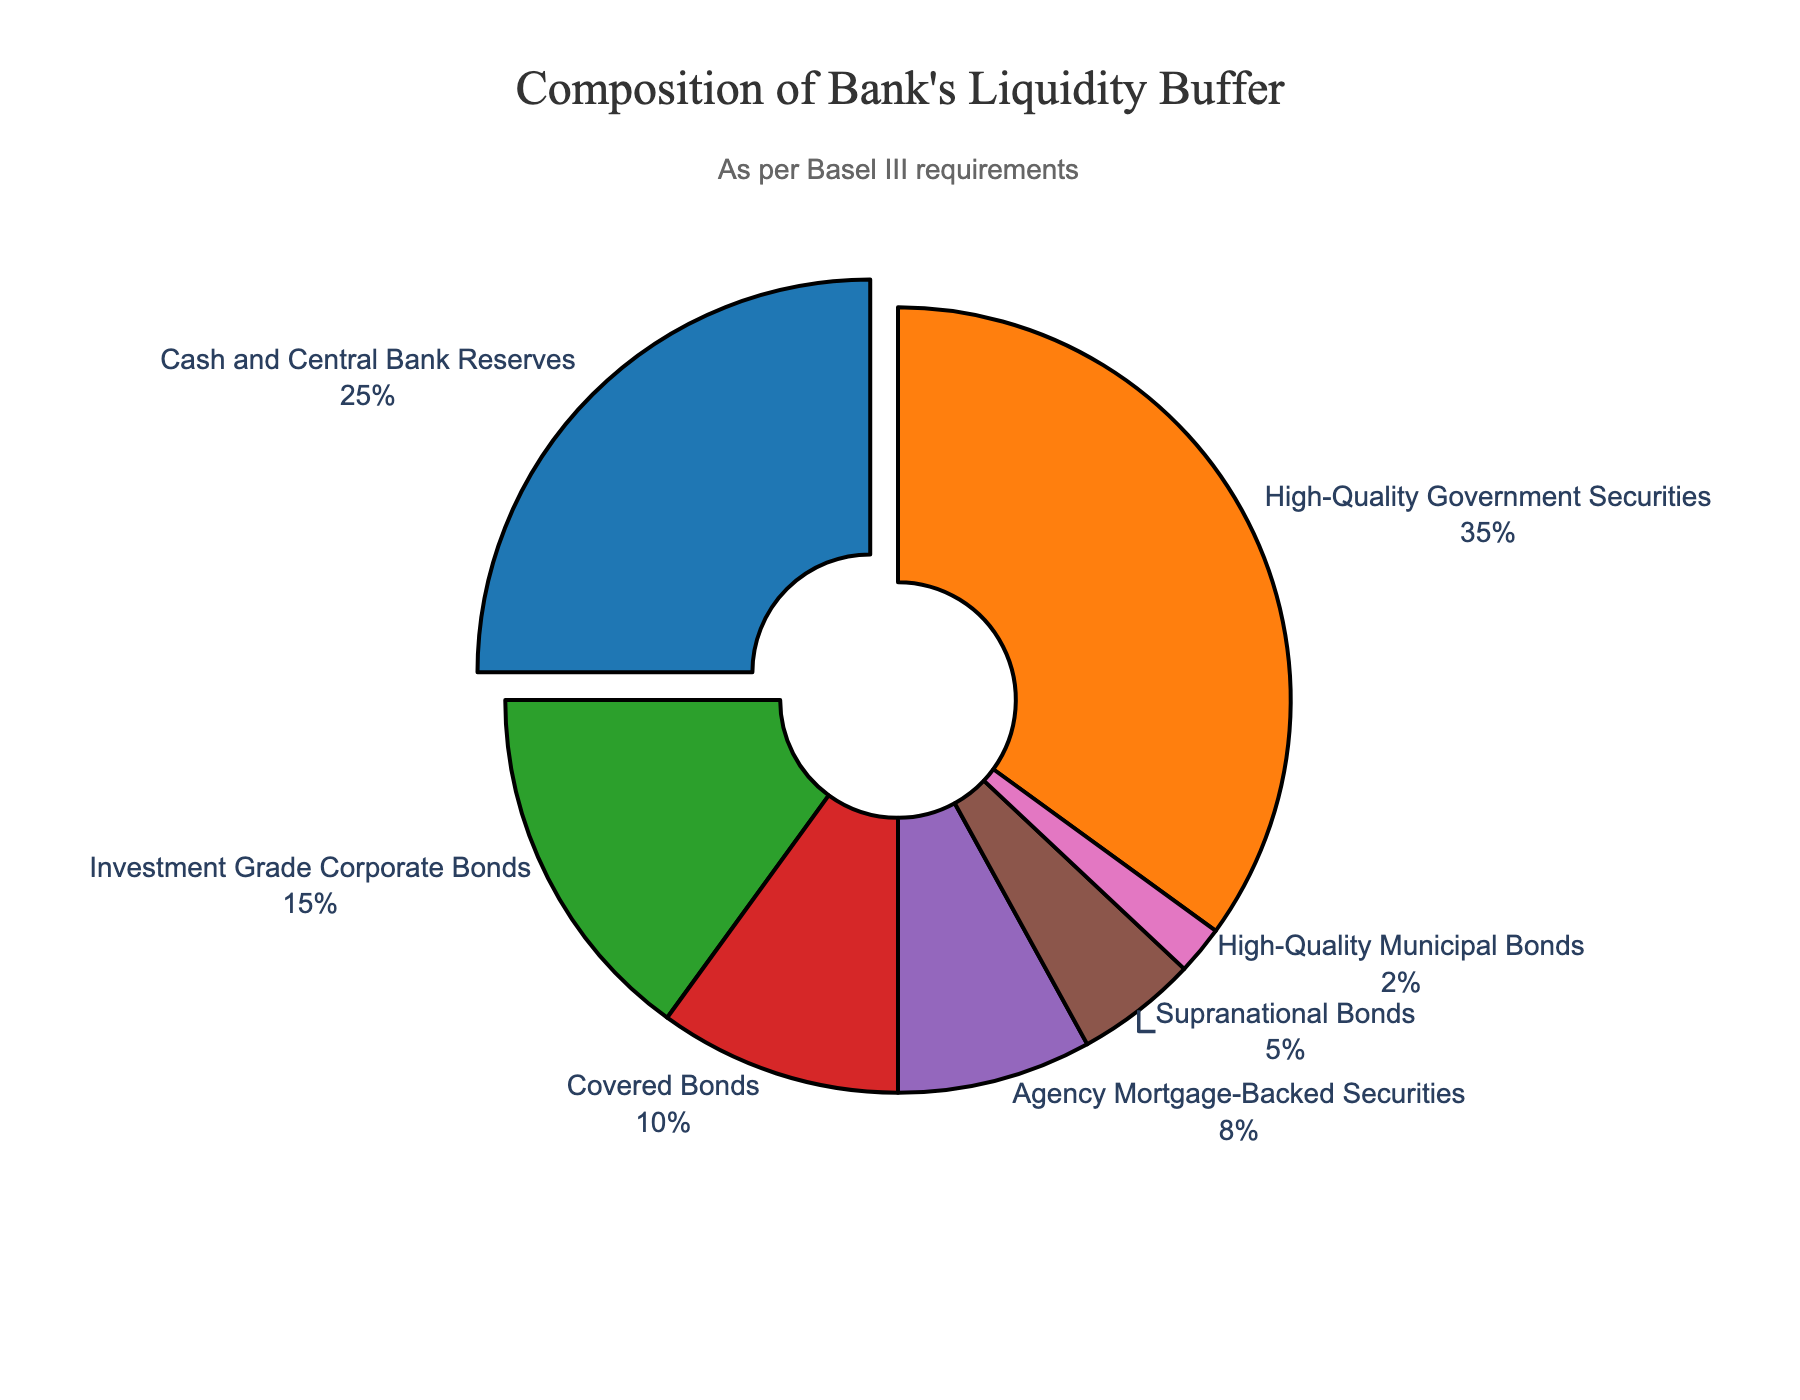What percentage of the bank's liquidity buffer is held in cash and central bank reserves and agency mortgage-backed securities combined? Sum the individual percentages labeled in the plot: 25% (Cash and Central Bank Reserves) + 8% (Agency Mortgage-Backed Securities) = 33%
Answer: 33% Which asset type represents the largest proportion of the bank's liquidity buffer? Identify the segment with the largest percentage in the plot: High-Quality Government Securities (35%)
Answer: High-Quality Government Securities What is the difference in percentage between the shares of high-quality government securities and investment grade corporate bonds? Subtract the percentage of Investment Grade Corporate Bonds from High-Quality Government Securities: 35% (High-Quality Government Securities) - 15% (Investment Grade Corporate Bonds) = 20%
Answer: 20% Does the sum of covered bonds and supranational bonds exceed the share of investment grade corporate bonds? Add the percentages of Covered Bonds and Supranational Bonds: 10% (Covered Bonds) + 5% (Supranational Bonds) = 15%. Compare with Investment Grade Corporate Bonds (15%): 15% is not greater than 15%
Answer: No Between covered bonds and agency mortgage-backed securities, which has a lower percentage in the liquidity buffer, and by how much? Compare the percentages of Covered Bonds (10%) and Agency Mortgage-Backed Securities (8%): Covered Bonds (10%) - Agency Mortgage-Backed Securities (8%) = 2%
Answer: Agency Mortgage-Backed Securities, by 2% How many asset types make up less than 10% each of the bank's liquidity buffer? Review the segments with percentages less than 10%: Investment Grade Corporate Bonds (15%), Covered Bonds (10%), Agency Mortgage-Backed Securities (8%), Supranational Bonds (5%), High-Quality Municipal Bonds (2%). Count the segments under 10%: 3 (8%, 5%, 2%)
Answer: 3 What percentage of the liquidity buffer is not held in high-quality government securities? Subtract the percentage for High-Quality Government Securities from 100%: 100% - 35% = 65%
Answer: 65% Which two asset types together make up exactly 15% of the bank's liquidity buffer? Identify segments that sum to 15%: Supranational Bonds (5%) + High-Quality Municipal Bonds (2%) + Covered Bonds (10%) = 2% + 10% = 12%, and Investment Grade Corporate Bonds (15%) + 0 = 15%
Answer: None (valid pair not found) What proportion of the liquidity buffer is made up of assets other than cash and central bank reserves? Subtract the percentage for Cash and Central Bank Reserves from 100%: 100% - 25% = 75%
Answer: 75% 